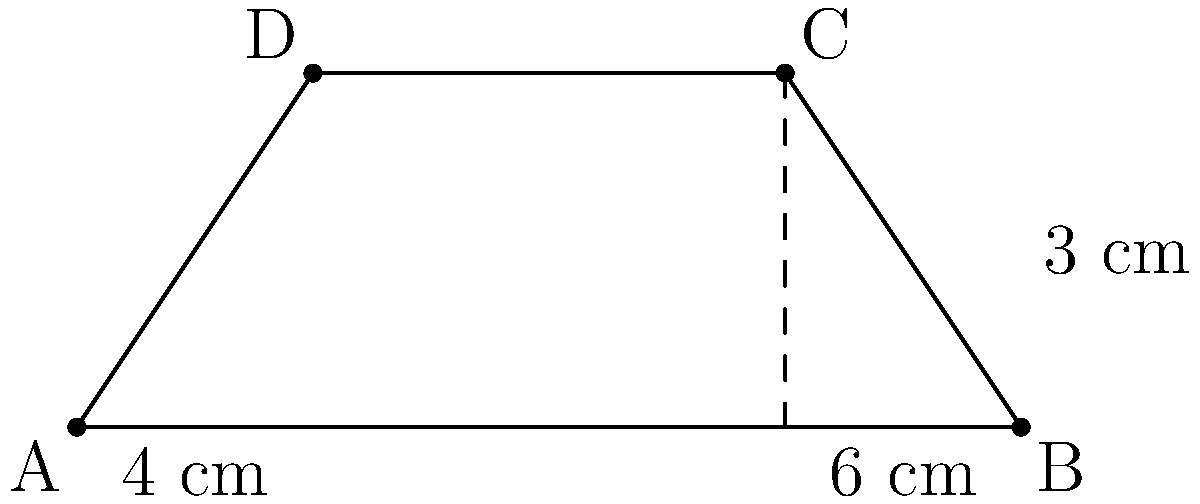In a bridge tournament, the playing area is shaped like a trapezoid. The parallel sides of the trapezoid measure 4 cm and 6 cm, and the height is 3 cm. What is the area of this playing space? To find the area of a trapezoid, we can use the formula:

$$A = \frac{1}{2}(b_1 + b_2)h$$

Where:
$A$ = Area
$b_1$ and $b_2$ = Lengths of the parallel sides
$h$ = Height of the trapezoid

Given:
$b_1 = 4$ cm
$b_2 = 6$ cm
$h = 3$ cm

Let's substitute these values into the formula:

$$A = \frac{1}{2}(4 + 6) \cdot 3$$

$$A = \frac{1}{2}(10) \cdot 3$$

$$A = 5 \cdot 3$$

$$A = 15$$

Therefore, the area of the trapezoid-shaped playing space is 15 square centimeters.
Answer: 15 cm² 